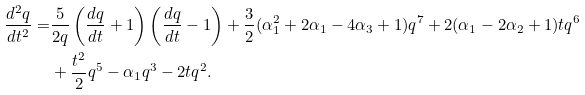<formula> <loc_0><loc_0><loc_500><loc_500>\frac { d ^ { 2 } q } { d t ^ { 2 } } = & \frac { 5 } { 2 q } \left ( \frac { d q } { d t } + 1 \right ) \left ( \frac { d q } { d t } - 1 \right ) + \frac { 3 } { 2 } ( \alpha _ { 1 } ^ { 2 } + 2 \alpha _ { 1 } - 4 \alpha _ { 3 } + 1 ) q ^ { 7 } + 2 ( \alpha _ { 1 } - 2 \alpha _ { 2 } + 1 ) t q ^ { 6 } \\ & + \frac { t ^ { 2 } } { 2 } q ^ { 5 } - \alpha _ { 1 } q ^ { 3 } - 2 t q ^ { 2 } .</formula> 